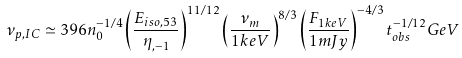Convert formula to latex. <formula><loc_0><loc_0><loc_500><loc_500>\nu _ { p , I C } \simeq 3 9 6 n _ { 0 } ^ { - 1 / 4 } \left ( \frac { E _ { i s o , 5 3 } } { \eta _ { , - 1 } } \right ) ^ { 1 1 / 1 2 } \left ( \frac { \nu _ { m } } { 1 k e V } \right ) ^ { 8 / 3 } \left ( \frac { F _ { 1 k e V } } { 1 m J y } \right ) ^ { - 4 / 3 } t _ { o b s } ^ { - 1 / 1 2 } G e V</formula> 